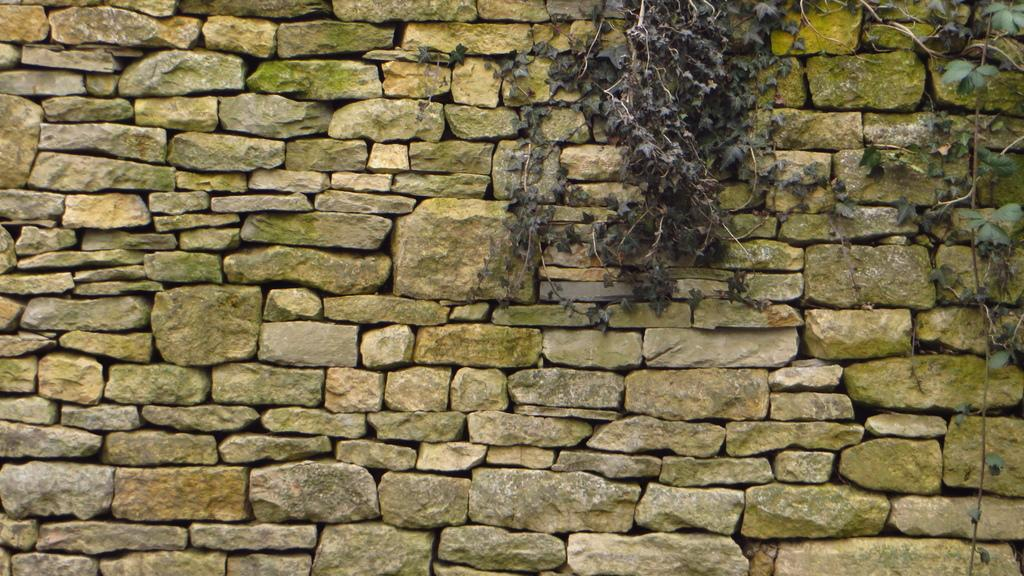What is the main subject of the image? The main subject of the image is planets. Where are the planets located in the image? The planets are on a stone wall. How many airplanes can be seen taking off from the airport in the image? There is no airport or airplanes present in the image; it features planets on a stone wall. What type of body is shown interacting with the planets in the image? There is no body shown interacting with the planets in the image; only the planets and the stone wall are present. 